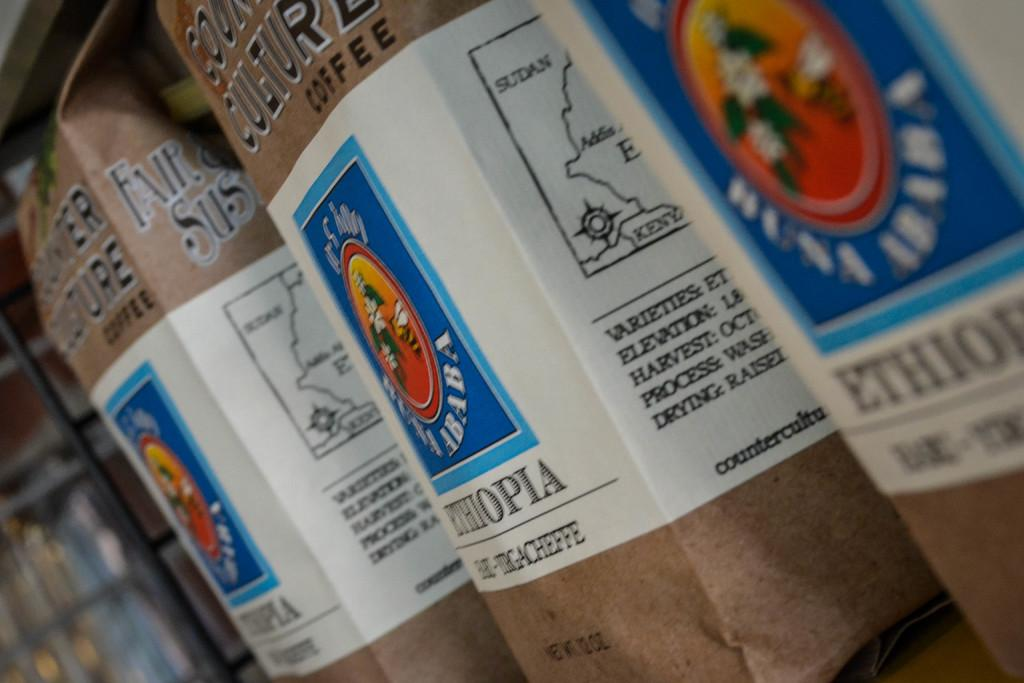<image>
Provide a brief description of the given image. bags of Coffee from Ethiopia on a shelf 